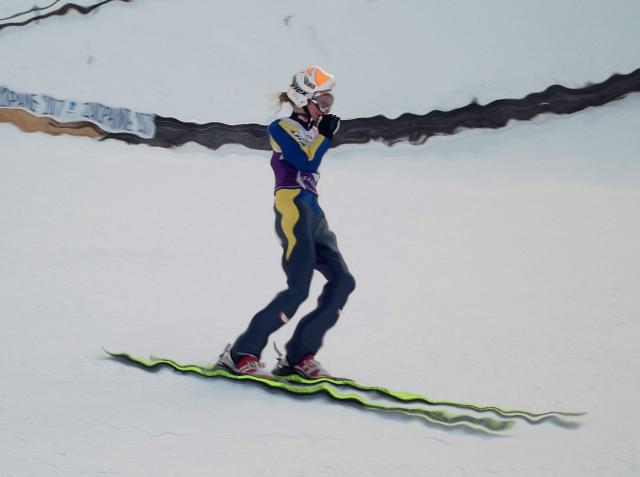Is there visible noise in the image? The image appears to be of high quality with no noticeable noise disrupting the visual clarity. It's a clean shot that captures the action without any graininess or artifacts that could detract from the viewing experience. 